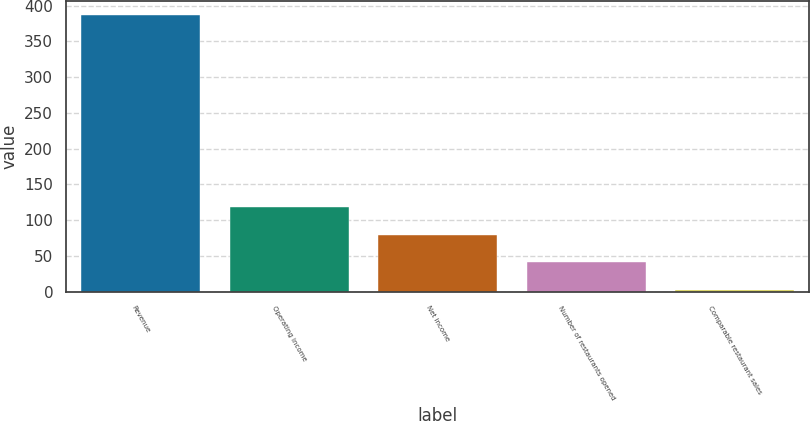<chart> <loc_0><loc_0><loc_500><loc_500><bar_chart><fcel>Revenue<fcel>Operating income<fcel>Net income<fcel>Number of restaurants opened<fcel>Comparable restaurant sales<nl><fcel>387.6<fcel>118.17<fcel>79.68<fcel>41.19<fcel>2.7<nl></chart> 